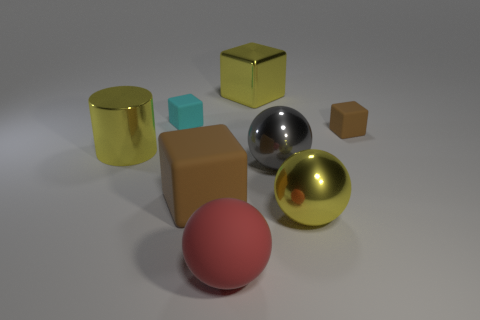There is a brown rubber thing that is on the left side of the yellow sphere; how big is it?
Your response must be concise. Large. Is there any other thing of the same color as the matte sphere?
Your answer should be very brief. No. Is there a large metal object left of the block that is in front of the yellow metal object to the left of the cyan cube?
Your answer should be very brief. Yes. Do the small matte object that is left of the large yellow ball and the large cylinder have the same color?
Your answer should be very brief. No. How many cubes are cyan rubber objects or gray things?
Your answer should be compact. 1. There is a tiny matte object behind the brown thing behind the big gray sphere; what shape is it?
Offer a very short reply. Cube. What is the size of the yellow object that is left of the yellow metal object that is behind the rubber object to the right of the big yellow ball?
Provide a short and direct response. Large. Do the gray metal object and the yellow metallic cylinder have the same size?
Your answer should be very brief. Yes. What number of things are shiny cylinders or rubber balls?
Your response must be concise. 2. There is a yellow metallic object left of the brown object in front of the big yellow cylinder; how big is it?
Provide a short and direct response. Large. 